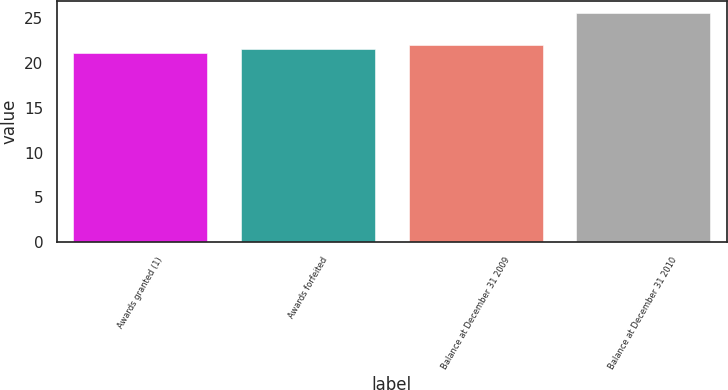Convert chart. <chart><loc_0><loc_0><loc_500><loc_500><bar_chart><fcel>Awards granted (1)<fcel>Awards forfeited<fcel>Balance at December 31 2009<fcel>Balance at December 31 2010<nl><fcel>21.11<fcel>21.56<fcel>22.01<fcel>25.62<nl></chart> 